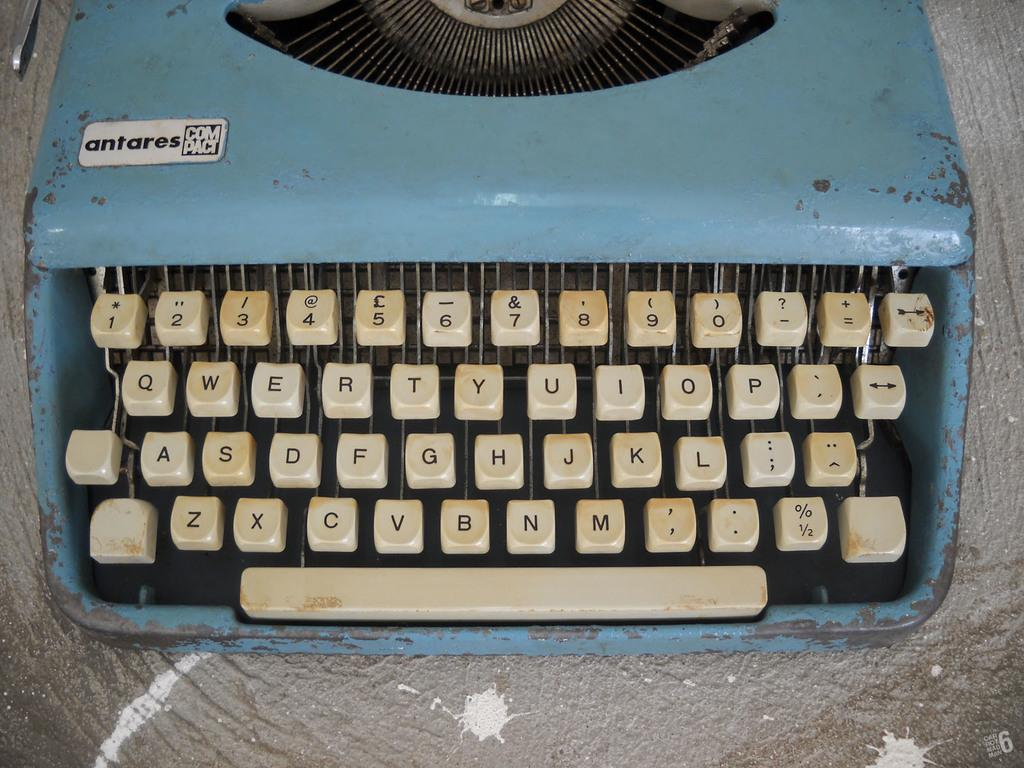<image>
Summarize the visual content of the image. An old antares typewriter is blue and has white keys 